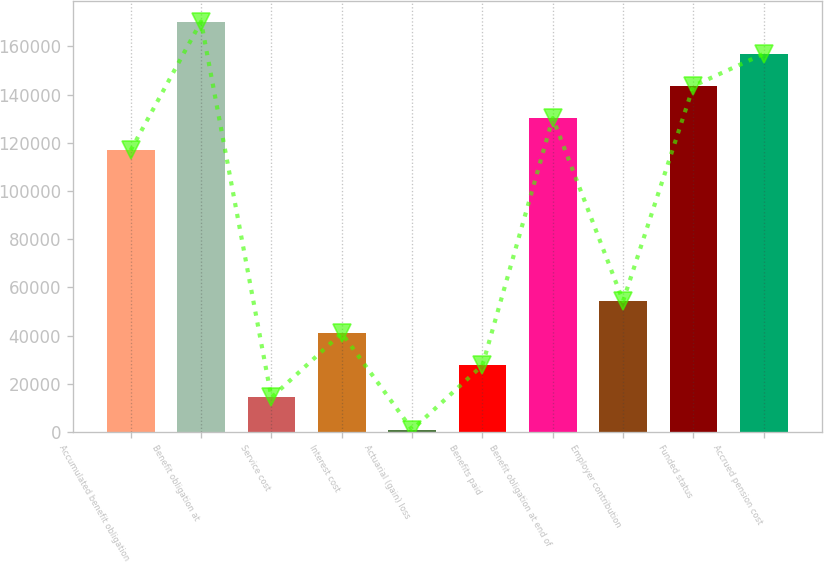Convert chart to OTSL. <chart><loc_0><loc_0><loc_500><loc_500><bar_chart><fcel>Accumulated benefit obligation<fcel>Benefit obligation at<fcel>Service cost<fcel>Interest cost<fcel>Actuarial (gain) loss<fcel>Benefits paid<fcel>Benefit obligation at end of<fcel>Employer contribution<fcel>Funded status<fcel>Accrued pension cost<nl><fcel>116943<fcel>170327<fcel>14366<fcel>41058<fcel>1020<fcel>27712<fcel>130289<fcel>54404<fcel>143635<fcel>156981<nl></chart> 